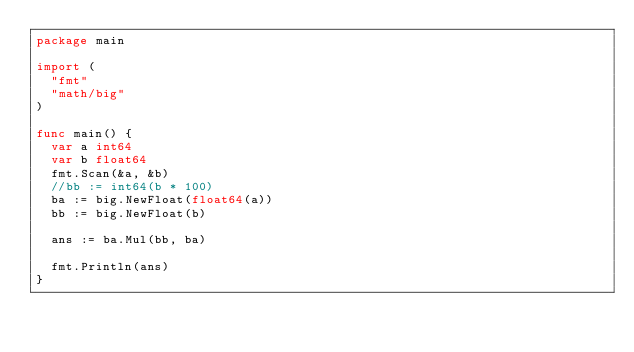Convert code to text. <code><loc_0><loc_0><loc_500><loc_500><_Go_>package main

import (
	"fmt"
	"math/big"
)

func main() {
	var a int64
	var b float64
	fmt.Scan(&a, &b)
	//bb := int64(b * 100)
	ba := big.NewFloat(float64(a))
	bb := big.NewFloat(b)

	ans := ba.Mul(bb, ba)

	fmt.Println(ans)
}
</code> 